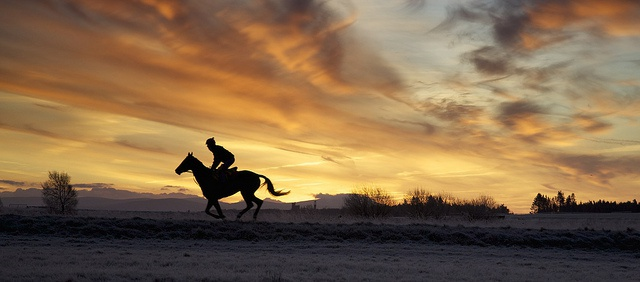Describe the objects in this image and their specific colors. I can see horse in maroon, black, khaki, and tan tones and people in maroon, black, olive, and tan tones in this image. 